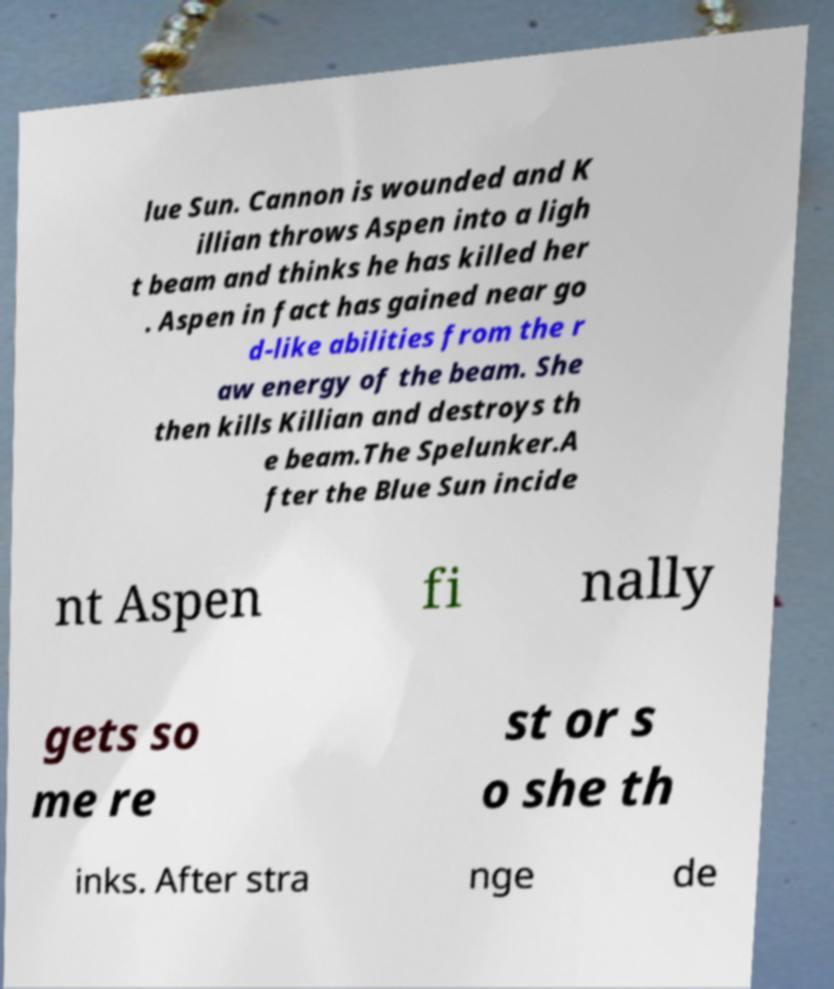Could you assist in decoding the text presented in this image and type it out clearly? lue Sun. Cannon is wounded and K illian throws Aspen into a ligh t beam and thinks he has killed her . Aspen in fact has gained near go d-like abilities from the r aw energy of the beam. She then kills Killian and destroys th e beam.The Spelunker.A fter the Blue Sun incide nt Aspen fi nally gets so me re st or s o she th inks. After stra nge de 